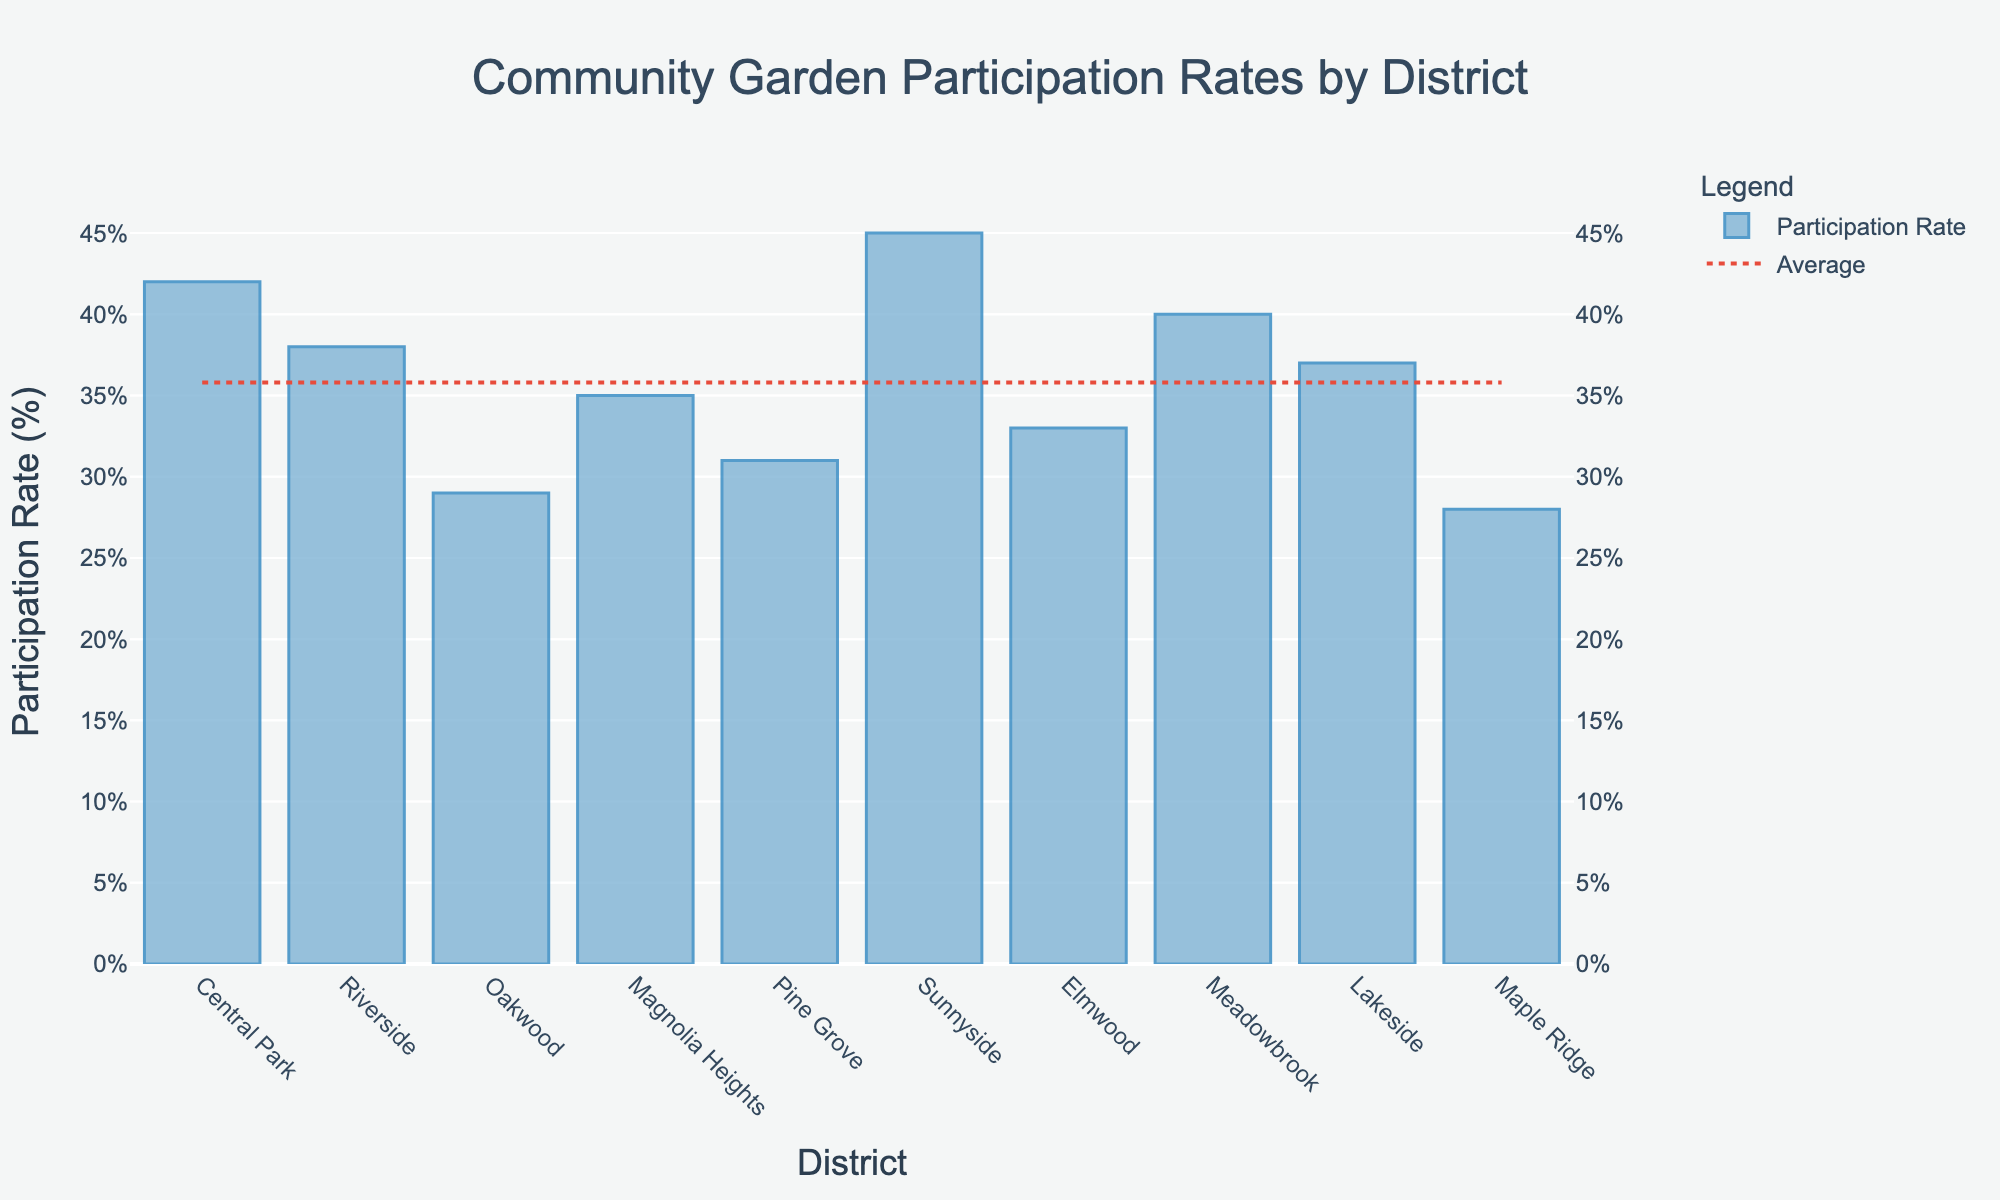Which district has the highest participation rate? The district with the highest bar represents the district with the highest participation rate. In this figure, Sunnyside has the highest bar.
Answer: Sunnyside Which district has the lowest participation rate? The district with the shortest bar represents the district with the lowest participation rate. In this figure, Maple Ridge has the shortest bar.
Answer: Maple Ridge How does the participation rate of Central Park compare to the average participation rate? First, identify the participation rate for Central Park, which is 42%. Next, compare this rate to the horizontal dot-dash line representing the average rate. Since Central Park's rate is 42%, and the average is 35.8%, Central Park's rate is above the average.
Answer: Above the average What is the difference in participation rate between Sunnyside and Oakwood? Find the participation rates for Sunnyside (45%) and Oakwood (29%), then subtract Oakwood's rate from Sunnyside's rate: 45% - 29% = 16%.
Answer: 16% Which districts have participation rates above the average? Identify the districts with bars higher than the average line (35.8%). These districts are Central Park (42%), Riverside (38%), Magnolia Heights (35%), Sunnyside (45%), Meadowbrook (40%), and Lakeside (37%).
Answer: Central Park, Riverside, Magnolia Heights, Sunnyside, Meadowbrook, Lakeside How many districts have a participation rate below 30%? Identify the bars with heights representing rates below 30%. Only Oakwood (29%) and Maple Ridge (28%) fall under this category.
Answer: 2 What is the average participation rate in the community gardens? The average participation rate is represented by the horizontal dot-dash line. Refer to this line to find the value, which is stated as 35.8%.
Answer: 35.8% In terms of visual height, which district has a bar closest to the average participation rate? Compare the height of the average line to the bars. Several bars are close, but Magnolia Heights, with its participation rate of 35%, is the closest to the average of 35.8%.
Answer: Magnolia Heights What is the participation rate of Elmwood, and how does it compare with Pine Grove? Elmwood's participation rate is 33%. Pine Grove’s participation rate is 31%. Comparing the two, Elmwood has a slightly higher rate.
Answer: Elmwood is higher than Pine Grove By how much does Meadowbrook's participation rate exceed that of Maple Ridge? Find the participation rates for Meadowbrook (40%) and Maple Ridge (28%), then subtract Maple Ridge's rate from Meadowbrook's rate: 40% - 28% = 12%.
Answer: 12% 